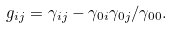<formula> <loc_0><loc_0><loc_500><loc_500>g _ { i j } = \gamma _ { i j } - \gamma _ { 0 i } \gamma _ { 0 j } / \gamma _ { 0 0 } .</formula> 